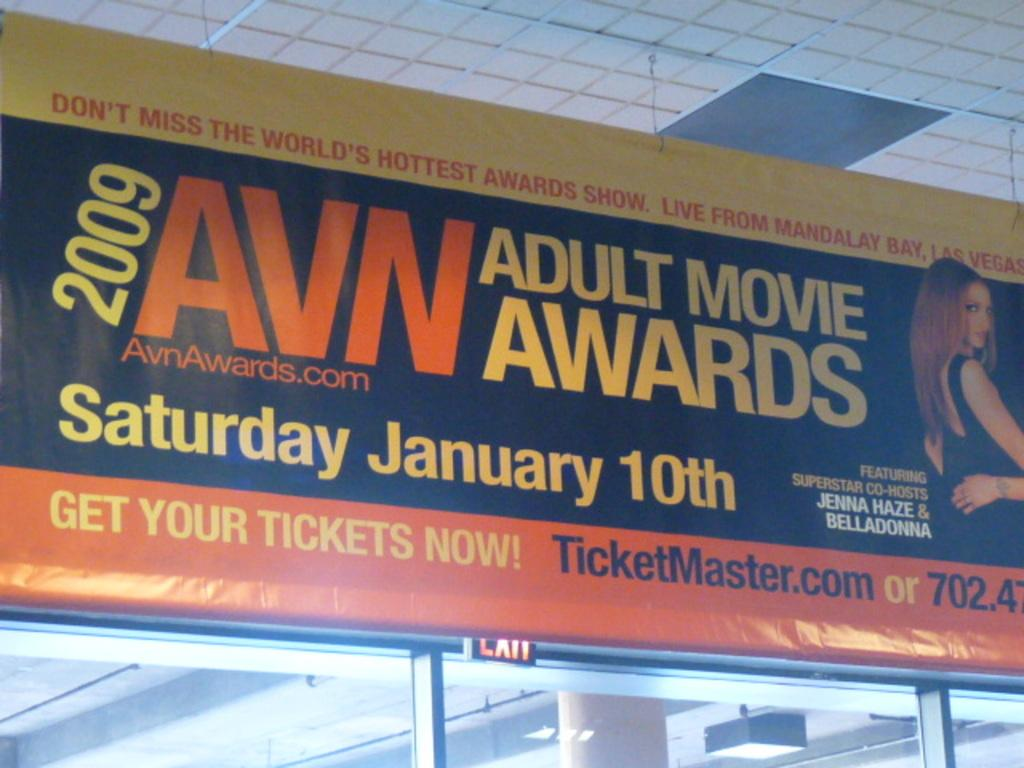<image>
Write a terse but informative summary of the picture. An advertisement for the 2009 adult movie awards 